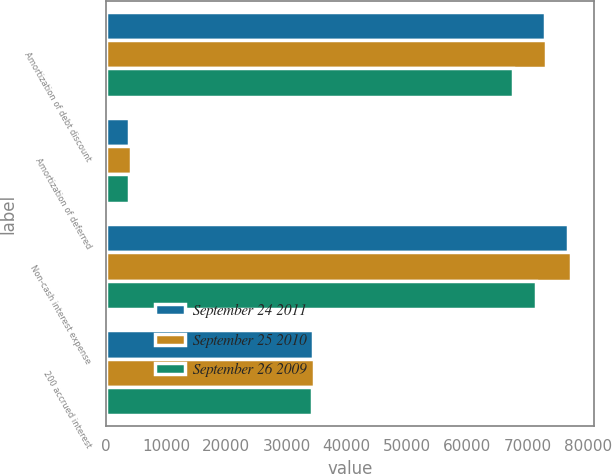<chart> <loc_0><loc_0><loc_500><loc_500><stacked_bar_chart><ecel><fcel>Amortization of debt discount<fcel>Amortization of deferred<fcel>Non-cash interest expense<fcel>200 accrued interest<nl><fcel>September 24 2011<fcel>72908<fcel>3906<fcel>76814<fcel>34427<nl><fcel>September 25 2010<fcel>73130<fcel>4092<fcel>77222<fcel>34500<nl><fcel>September 26 2009<fcel>67673<fcel>3786<fcel>71459<fcel>34269<nl></chart> 